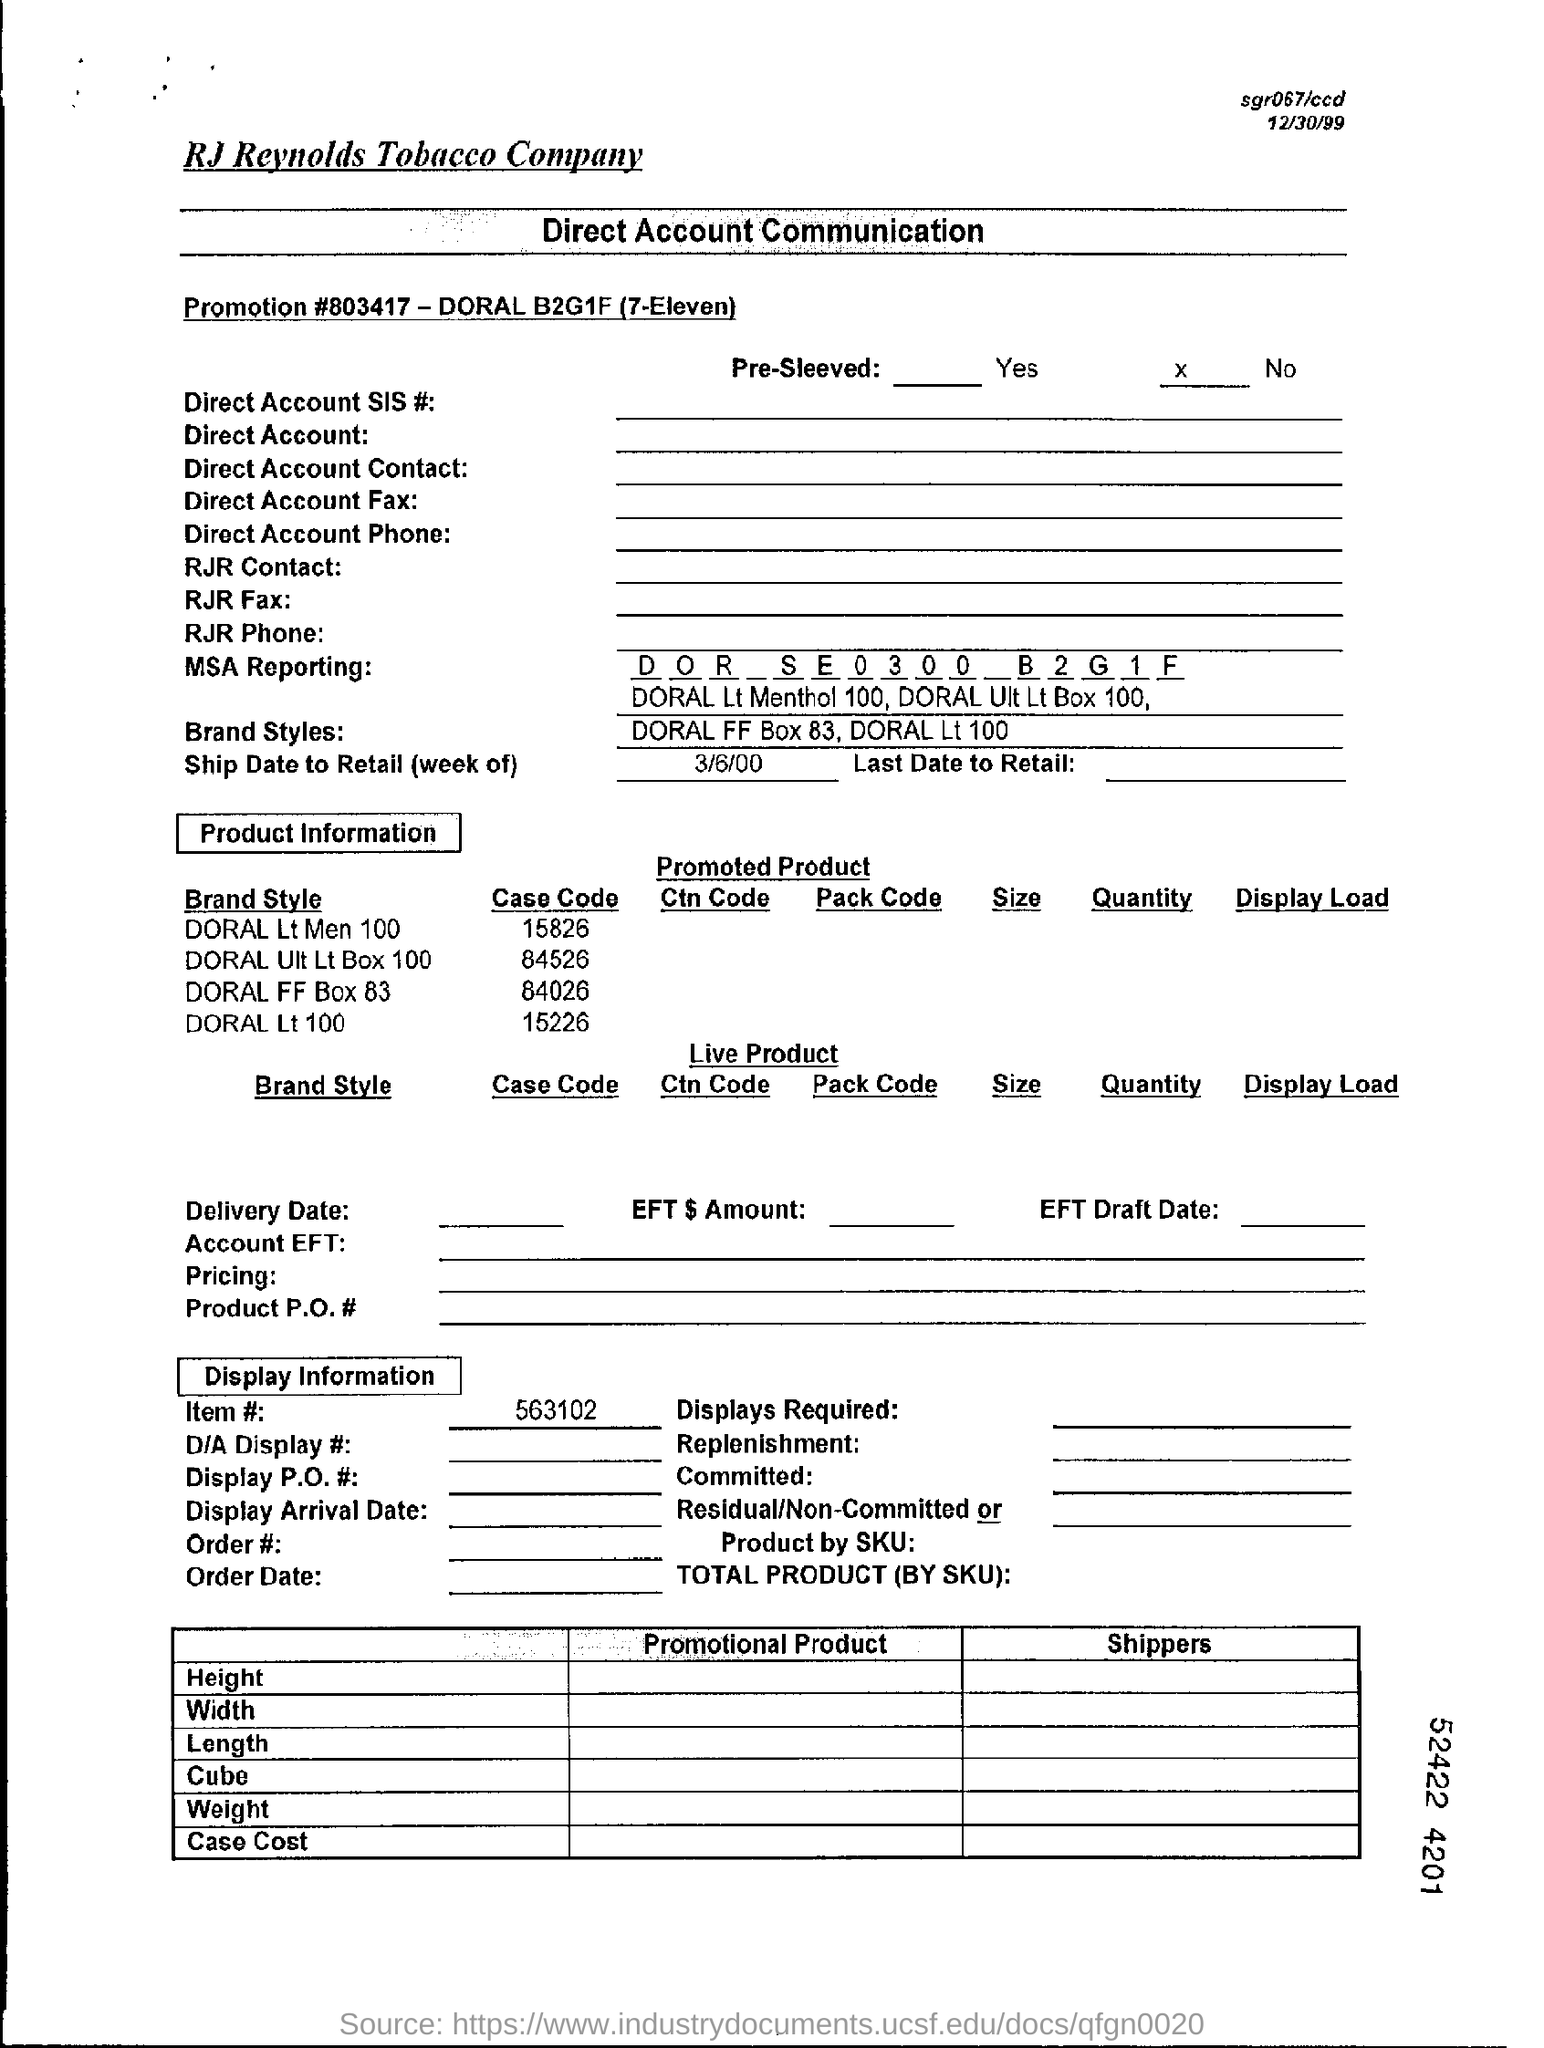What is the item no mentioned in the document?
Provide a succinct answer. 563102. What is the ship date to retail?
Offer a terse response. 3/6/00. What is the Promotion #  mentioned in the document?
Your answer should be compact. 803417. What is the case code for DORAL Lt 100?
Offer a very short reply. 15226. 